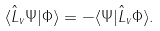<formula> <loc_0><loc_0><loc_500><loc_500>\langle \hat { L } _ { v } \Psi | \Phi \rangle = - \langle \Psi | \hat { L } _ { v } \Phi \rangle .</formula> 